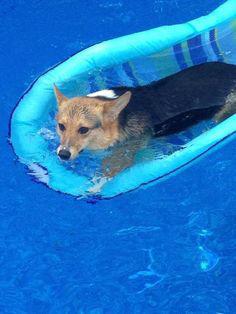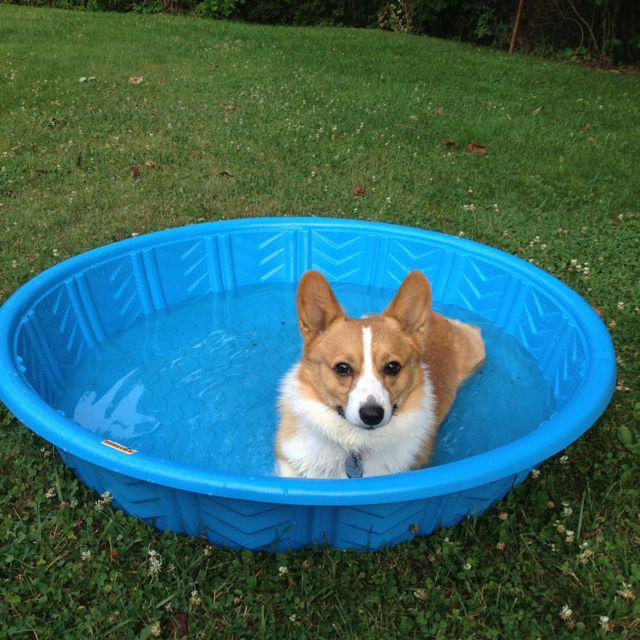The first image is the image on the left, the second image is the image on the right. Analyze the images presented: Is the assertion "In one image there is a corgi riding on a raft in a pool and the other shows at least one dog in a kiddie pool." valid? Answer yes or no. Yes. 